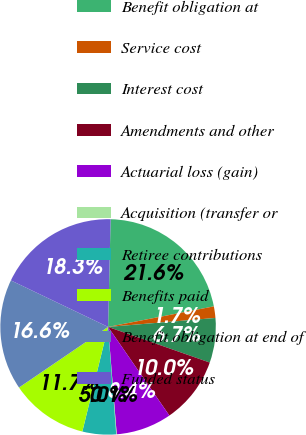Convert chart. <chart><loc_0><loc_0><loc_500><loc_500><pie_chart><fcel>Benefit obligation at<fcel>Service cost<fcel>Interest cost<fcel>Amendments and other<fcel>Actuarial loss (gain)<fcel>Acquisition (transfer or<fcel>Retiree contributions<fcel>Benefits paid<fcel>Benefit obligation at end of<fcel>Funded status<nl><fcel>21.57%<fcel>1.73%<fcel>6.69%<fcel>10.0%<fcel>8.35%<fcel>0.08%<fcel>5.04%<fcel>11.65%<fcel>16.61%<fcel>18.27%<nl></chart> 